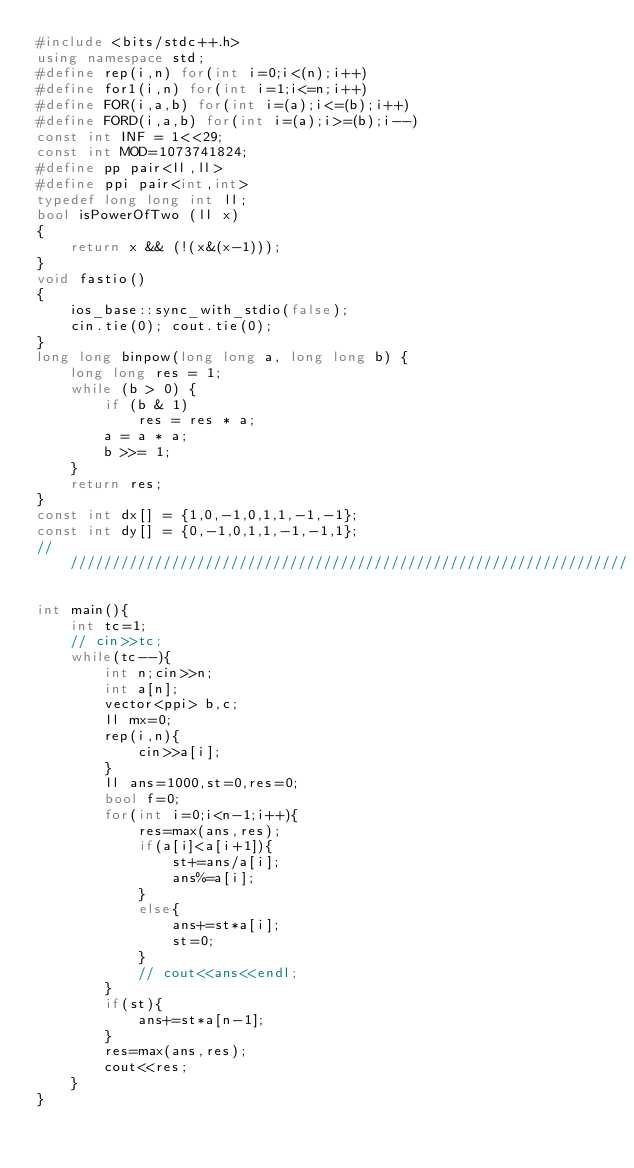Convert code to text. <code><loc_0><loc_0><loc_500><loc_500><_C++_>#include <bits/stdc++.h>
using namespace std; 
#define rep(i,n) for(int i=0;i<(n);i++)
#define for1(i,n) for(int i=1;i<=n;i++)
#define FOR(i,a,b) for(int i=(a);i<=(b);i++)
#define FORD(i,a,b) for(int i=(a);i>=(b);i--)
const int INF = 1<<29;
const int MOD=1073741824;
#define pp pair<ll,ll>
#define ppi pair<int,int>
typedef long long int ll;
bool isPowerOfTwo (ll x)  
{  
    return x && (!(x&(x-1)));  
}
void fastio()
{
    ios_base::sync_with_stdio(false);
    cin.tie(0); cout.tie(0);
}
long long binpow(long long a, long long b) {
    long long res = 1;
    while (b > 0) {
        if (b & 1)
            res = res * a;
        a = a * a;
        b >>= 1;
    }
    return res;
}
const int dx[] = {1,0,-1,0,1,1,-1,-1};
const int dy[] = {0,-1,0,1,1,-1,-1,1};
////////////////////////////////////////////////////////////////////

int main(){
    int tc=1;
    // cin>>tc;
    while(tc--){
        int n;cin>>n;
        int a[n];
        vector<ppi> b,c;
        ll mx=0;
        rep(i,n){
            cin>>a[i];
        }
        ll ans=1000,st=0,res=0;
        bool f=0;
        for(int i=0;i<n-1;i++){
            res=max(ans,res);
            if(a[i]<a[i+1]){
                st+=ans/a[i];
                ans%=a[i];
            }
            else{
                ans+=st*a[i];
                st=0;
            }
            // cout<<ans<<endl;
        }
        if(st){
            ans+=st*a[n-1];
        }
        res=max(ans,res);
        cout<<res;
    }
}</code> 